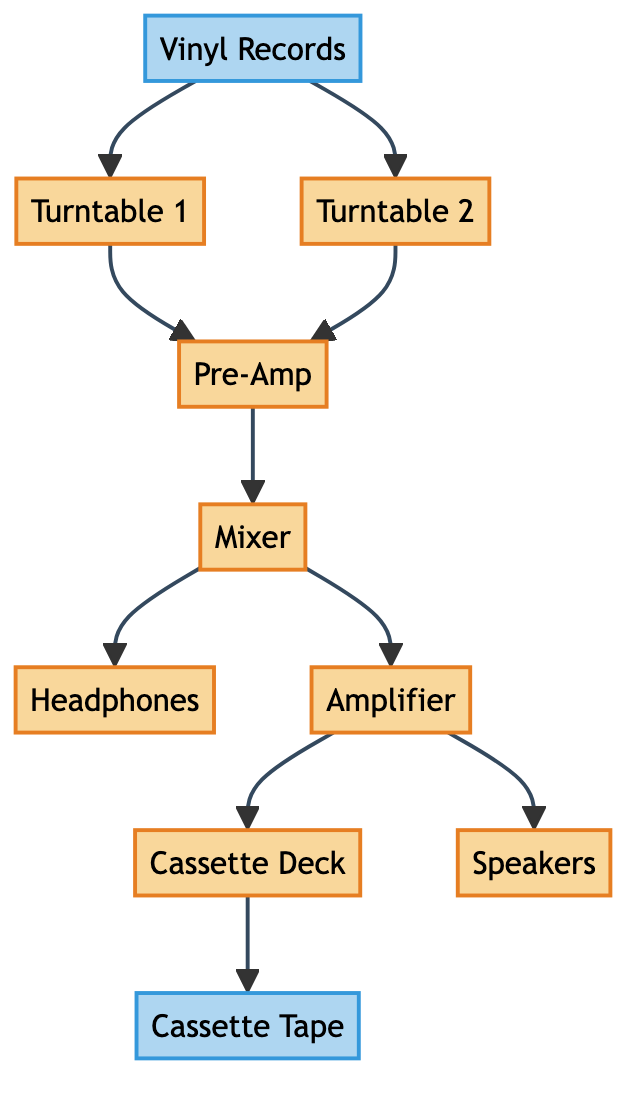What are the two types of turntables in the diagram? The diagram indicates two turntables, labeled "Turntable 1" and "Turntable 2." These are specifically named and shown as separate elements in the workflow.
Answer: Turntable 1 and Turntable 2 How many total pieces of equipment are listed in the diagram? Counting all unique equipment items in the diagram: Turntable 1, Turntable 2, Mixer, Headphones, Cassette Deck, Pre-Amp, Amplifier, and Speakers, totals to eight distinct pieces of equipment.
Answer: 8 What is the function of the mixer in this workflow? According to the diagram, the mixer blends and transitions audio signals that come from both turntables, making it a central hub for combining the audio inputs.
Answer: Blending audio signals Which component comes after the pre-amp in the signal flow? The arrow from the pre-amp points to the mixer, meaning that the next step in the workflow after the pre-amp involves the mixer receiving the boosted audio signal for further processing.
Answer: Mixer What is the final medium used to store the mixtape audio? The flow indicates that the cassette deck records the mixed audio and subsequently writes it to a cassette tape as the final storage medium for the mixtape.
Answer: Cassette Tape How do the speakers connect in the workflow? The diagram shows that the speakers are connected later in the process from the amplifier, which means they monitor the audio signal right before it is finalized for recording onto the cassette tape.
Answer: From the amplifier What is the role of headphones in this system? The headphones allow the DJ to monitor and cue tracks, as displayed by the line connecting them directly from the mixer, highlighting their importance in the live mixing process.
Answer: Cueing tracks 